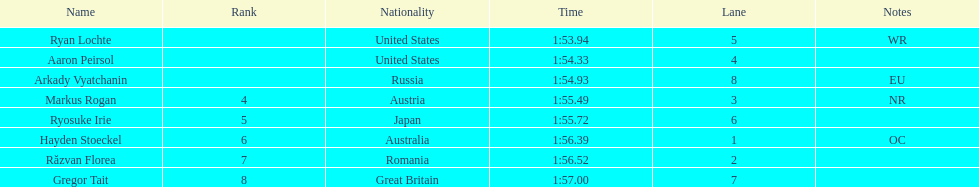Does russia or japan have the longer time? Japan. 